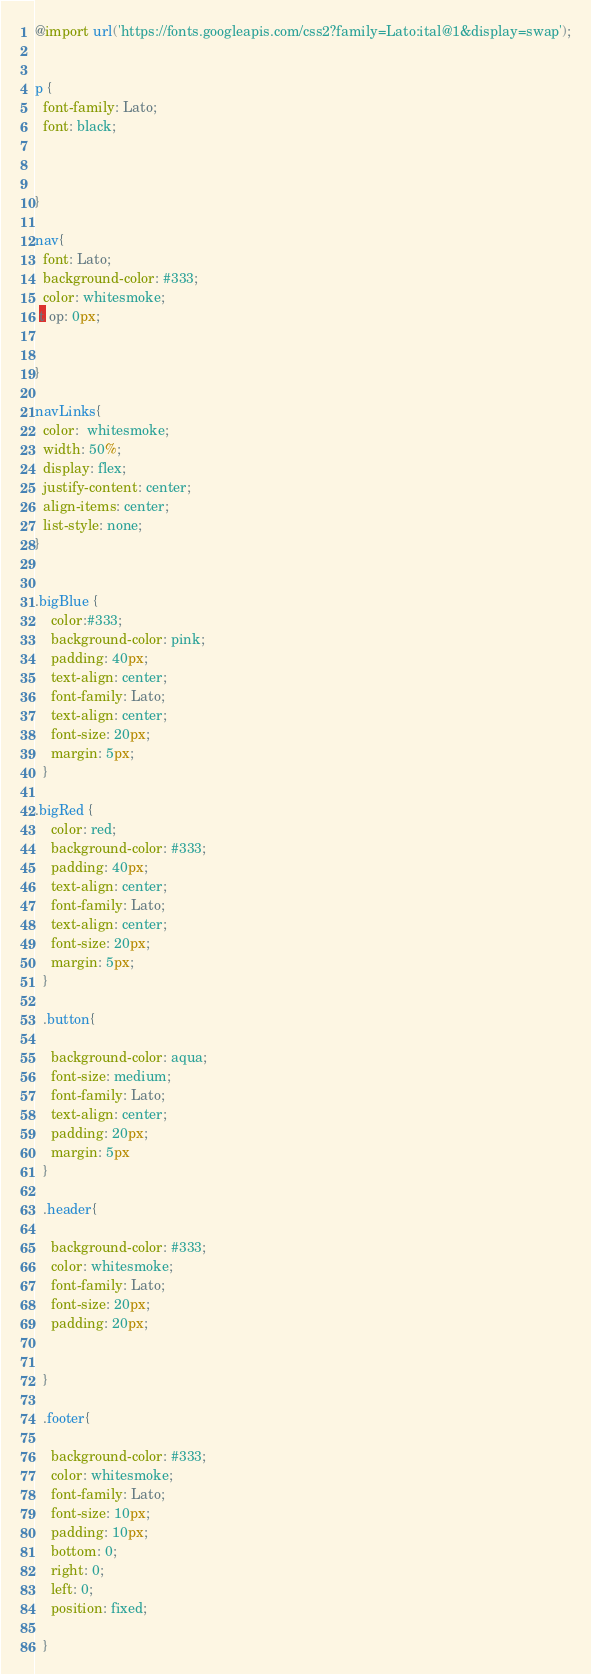<code> <loc_0><loc_0><loc_500><loc_500><_CSS_>@import url('https://fonts.googleapis.com/css2?family=Lato:ital@1&display=swap');


p {
  font-family: Lato;
  font: black;



}

nav{
  font: Lato;
  background-color: #333;
  color: whitesmoke;
 t op: 0px;


}

navLinks{
  color:  whitesmoke;
  width: 50%;
  display: flex;
  justify-content: center;
  align-items: center;
  list-style: none;
}


.bigBlue {
    color:#333;
    background-color: pink;
    padding: 40px;
    text-align: center;
    font-family: Lato;
    text-align: center;
    font-size: 20px;
    margin: 5px;
  }

.bigRed {
    color: red;
    background-color: #333;
    padding: 40px;
    text-align: center;
    font-family: Lato;
    text-align: center;
    font-size: 20px;
    margin: 5px;
  }

  .button{

    background-color: aqua;
    font-size: medium;
    font-family: Lato;
    text-align: center;
    padding: 20px;
    margin: 5px
  }

  .header{

    background-color: #333;
    color: whitesmoke;
    font-family: Lato;
    font-size: 20px;
    padding: 20px;
    
    
  }

  .footer{

    background-color: #333;
    color: whitesmoke;
    font-family: Lato;
    font-size: 10px;
    padding: 10px;
    bottom: 0;
    right: 0;
    left: 0;
    position: fixed;
    
  }</code> 